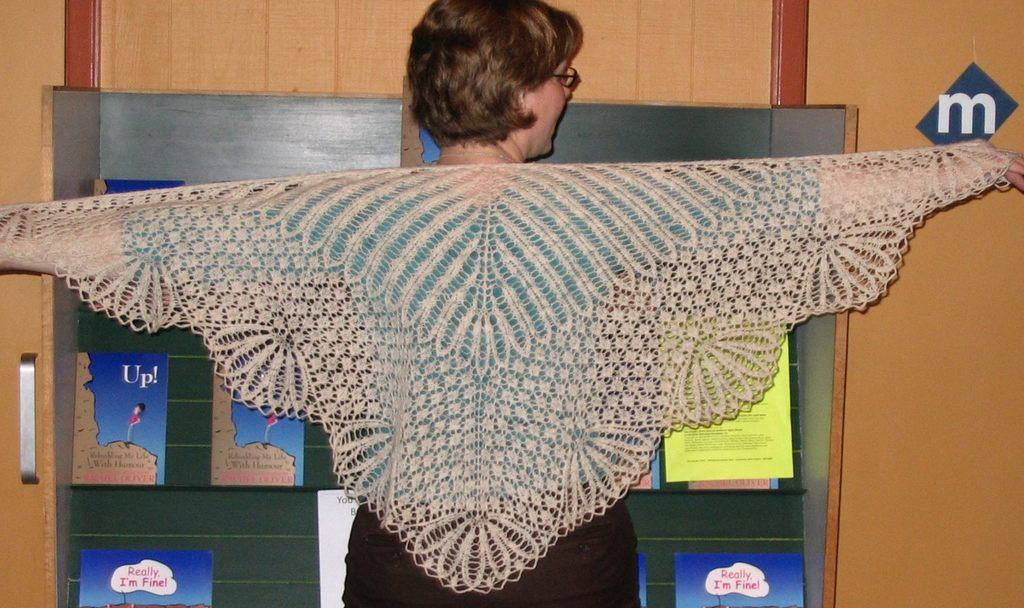Who is present in the image? There is a woman in the image. What can be seen on the board in the image? There are posters on a board in the image. What type of wall is visible in the background of the image? There is a wooden wall in the background of the image. What object can be seen in the background of the image? There is a handle in the background of the image. What type of cake is the queen holding in the image? There is no cake or queen present in the image. What toy can be seen on the wooden wall in the image? There are no toys visible on the wooden wall in the image. 